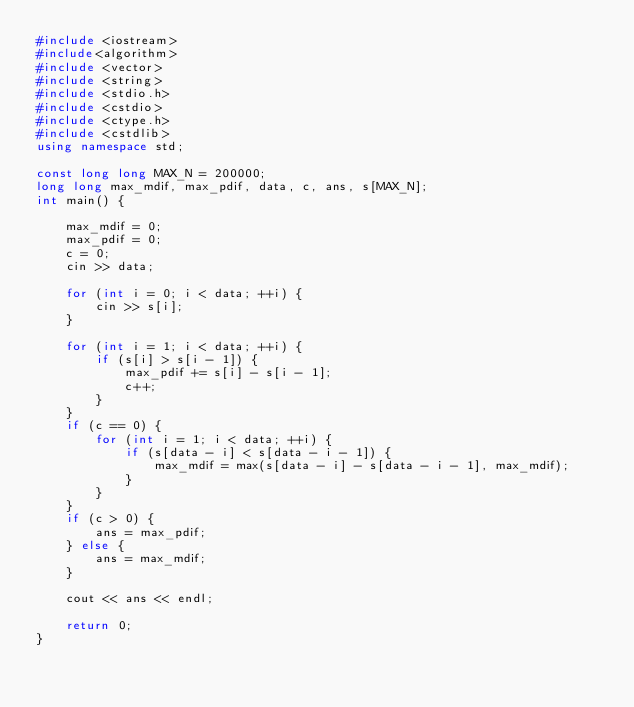Convert code to text. <code><loc_0><loc_0><loc_500><loc_500><_C++_>#include <iostream>
#include<algorithm>
#include <vector>
#include <string>
#include <stdio.h>
#include <cstdio>
#include <ctype.h>
#include <cstdlib>
using namespace std;

const long long MAX_N = 200000;
long long max_mdif, max_pdif, data, c, ans, s[MAX_N];
int main() {

	max_mdif = 0;
	max_pdif = 0;
	c = 0;
	cin >> data;

	for (int i = 0; i < data; ++i) {
		cin >> s[i];
	}

	for (int i = 1; i < data; ++i) {
		if (s[i] > s[i - 1]) {
			max_pdif += s[i] - s[i - 1];
			c++;
		}
	}
	if (c == 0) {
		for (int i = 1; i < data; ++i) {
			if (s[data - i] < s[data - i - 1]) {
				max_mdif = max(s[data - i] - s[data - i - 1], max_mdif);
			}
		}
	}
	if (c > 0) {
		ans = max_pdif;
	} else {
		ans = max_mdif;
	}

	cout << ans << endl;

	return 0;
}</code> 